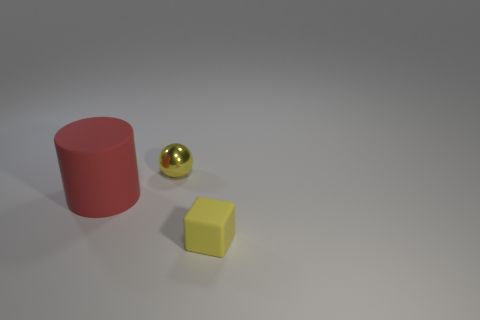Do the metal ball and the matte thing on the left side of the small yellow ball have the same color?
Your answer should be compact. No. Are there any red matte cylinders on the right side of the small metallic object?
Your answer should be compact. No. Is the size of the rubber object in front of the big red cylinder the same as the object that is to the left of the yellow sphere?
Your response must be concise. No. Are there any other yellow matte blocks of the same size as the yellow block?
Your answer should be very brief. No. There is a small object to the left of the small yellow matte thing; is it the same shape as the yellow matte thing?
Keep it short and to the point. No. What is the yellow object that is in front of the small yellow metallic thing made of?
Give a very brief answer. Rubber. What is the shape of the tiny yellow object that is behind the rubber object to the right of the big red cylinder?
Ensure brevity in your answer.  Sphere. There is a shiny object; is it the same shape as the yellow thing that is right of the tiny yellow metallic object?
Ensure brevity in your answer.  No. What number of yellow cubes are on the right side of the rubber object in front of the big red matte cylinder?
Your response must be concise. 0. What number of yellow objects are either balls or matte cubes?
Keep it short and to the point. 2. 